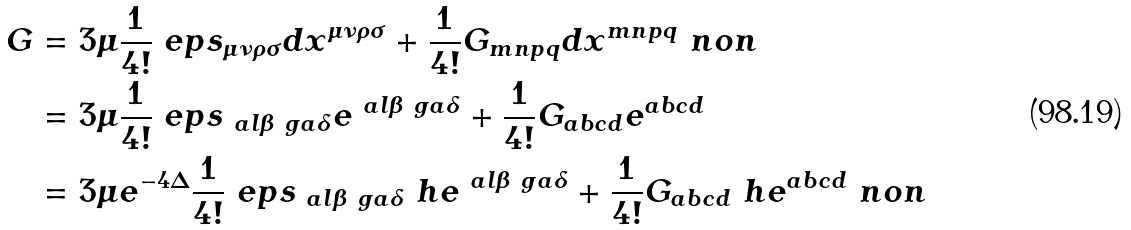<formula> <loc_0><loc_0><loc_500><loc_500>G & = 3 \mu \frac { 1 } { 4 ! } \ e p s _ { \mu \nu \rho \sigma } d x ^ { \mu \nu \rho \sigma } + \frac { 1 } { 4 ! } G _ { m n p q } d x ^ { m n p q } \ n o n \\ & = 3 \mu \frac { 1 } { 4 ! } \ e p s _ { \ a l \beta \ g a \delta } e ^ { \ a l \beta \ g a \delta } + \frac { 1 } { 4 ! } G _ { a b c d } e ^ { a b c d } \\ & = 3 \mu e ^ { - 4 \Delta } \frac { 1 } { 4 ! } \ e p s _ { \ a l \beta \ g a \delta } \ h e ^ { \ a l \beta \ g a \delta } + \frac { 1 } { 4 ! } G _ { a b c d } \ h e ^ { a b c d } \ n o n</formula> 